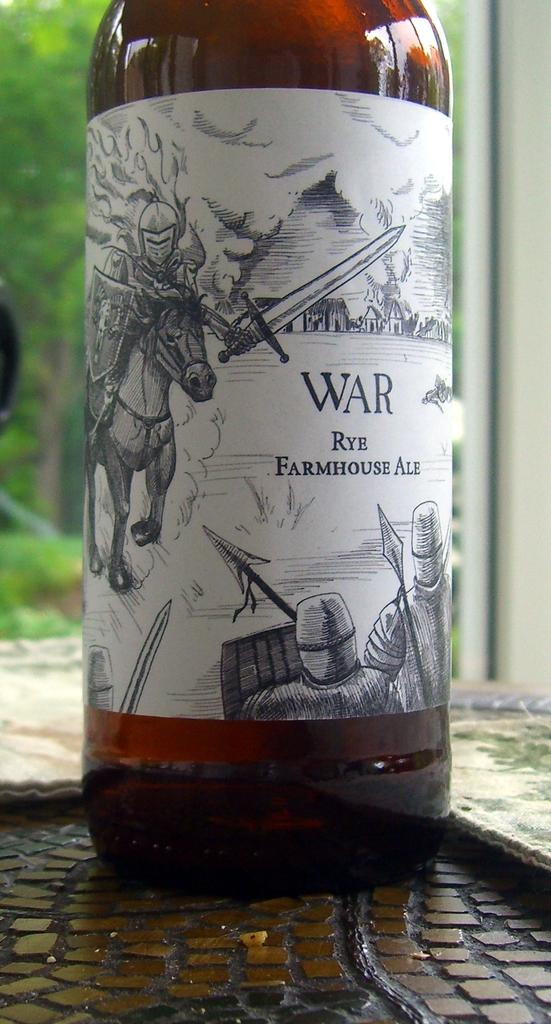<image>
Relay a brief, clear account of the picture shown. The beer shown is rye farmhouse ale and is called war 